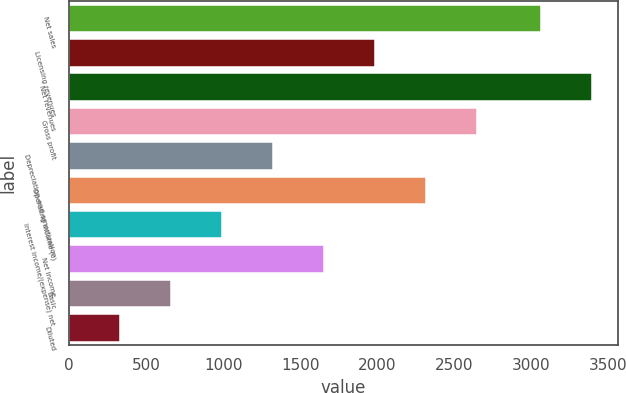<chart> <loc_0><loc_0><loc_500><loc_500><bar_chart><fcel>Net sales<fcel>Licensing revenues<fcel>Net revenues<fcel>Gross profit<fcel>Depreciation and amortization<fcel>Operating income (c)<fcel>Interest income/(expense) net<fcel>Net income<fcel>Basic<fcel>Diluted<nl><fcel>3060.7<fcel>1983.32<fcel>3391.22<fcel>2644.36<fcel>1322.28<fcel>2313.84<fcel>991.76<fcel>1652.8<fcel>661.24<fcel>330.72<nl></chart> 